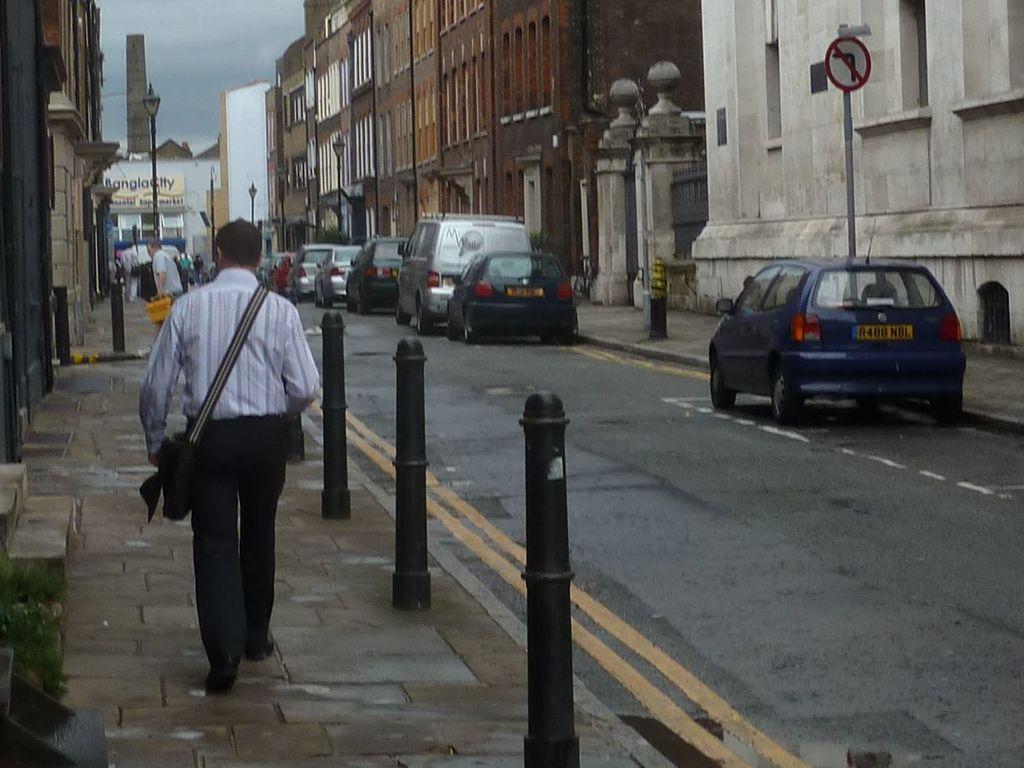How would you summarize this image in a sentence or two? In this image we can see a group of vehicles on the road and some people on the footpath. We can also see some poles, plants, the staircase, some buildings with windows, a signboard, some street poles and the sky which looks cloudy. 